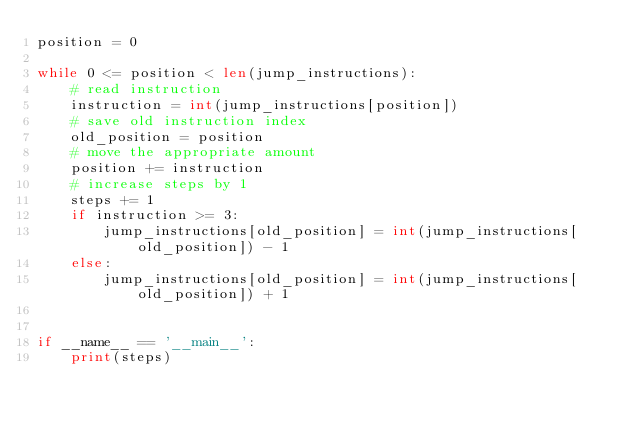Convert code to text. <code><loc_0><loc_0><loc_500><loc_500><_Python_>position = 0

while 0 <= position < len(jump_instructions):
    # read instruction
    instruction = int(jump_instructions[position])
    # save old instruction index
    old_position = position
    # move the appropriate amount
    position += instruction
    # increase steps by 1
    steps += 1
    if instruction >= 3:
        jump_instructions[old_position] = int(jump_instructions[old_position]) - 1
    else:
        jump_instructions[old_position] = int(jump_instructions[old_position]) + 1


if __name__ == '__main__':
    print(steps)
</code> 